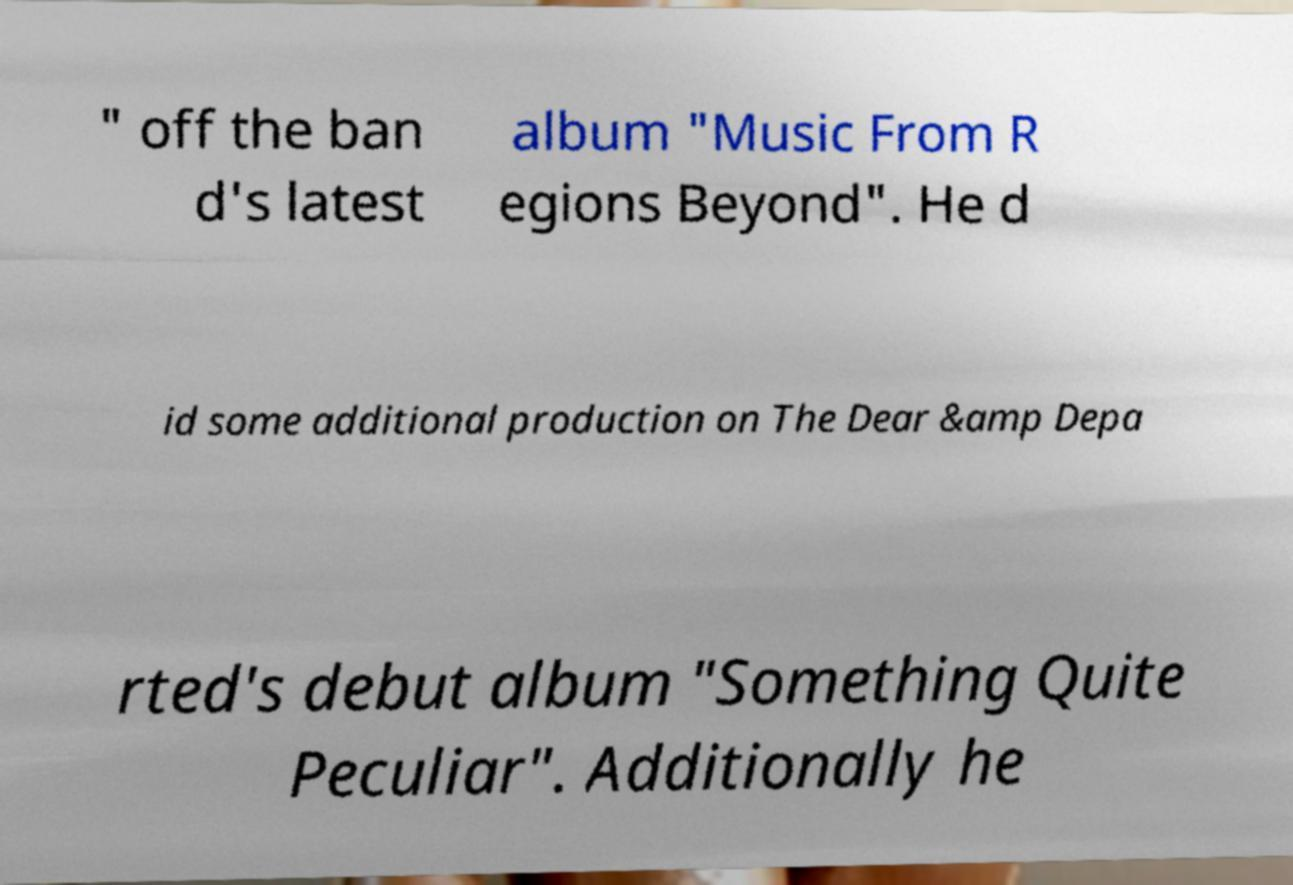There's text embedded in this image that I need extracted. Can you transcribe it verbatim? " off the ban d's latest album "Music From R egions Beyond". He d id some additional production on The Dear &amp Depa rted's debut album "Something Quite Peculiar". Additionally he 